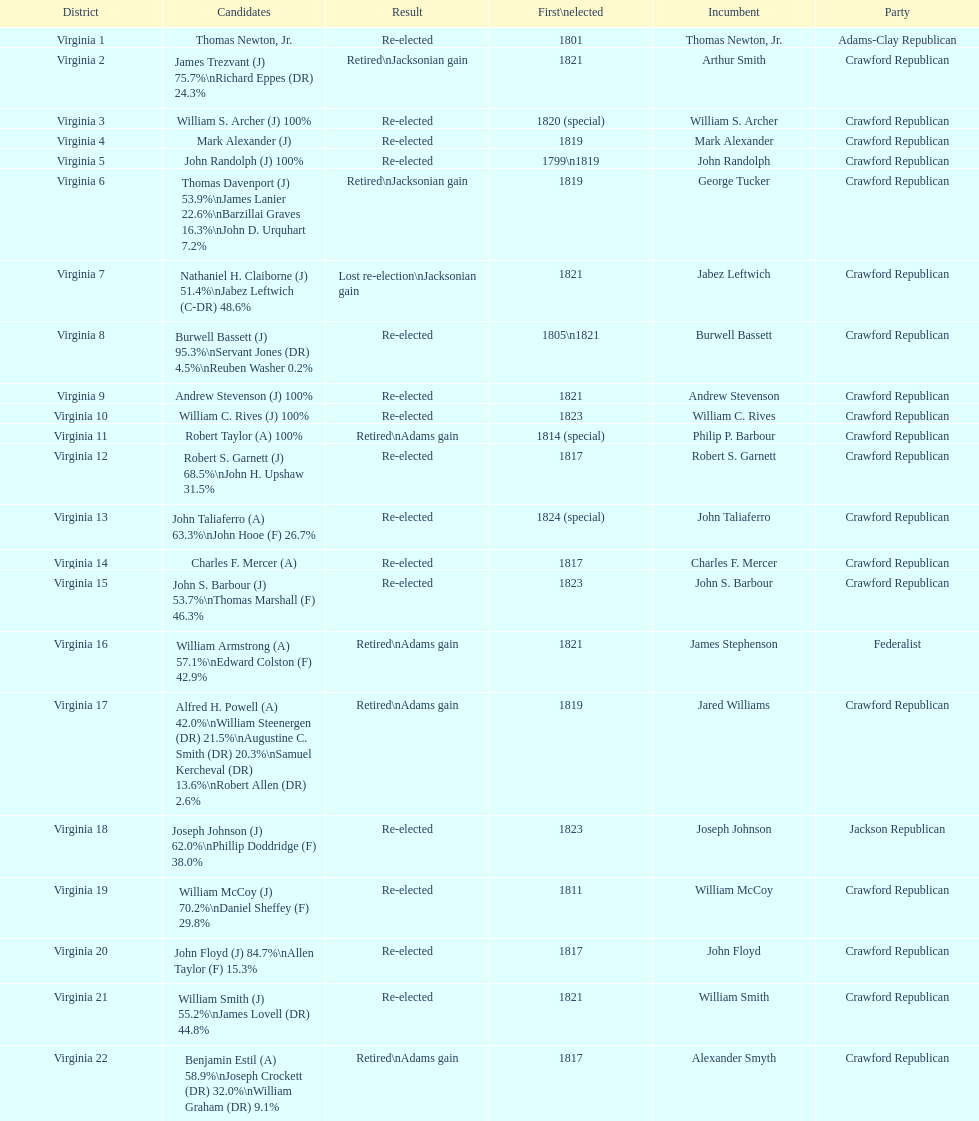Tell me the number of people first elected in 1817. 4. 